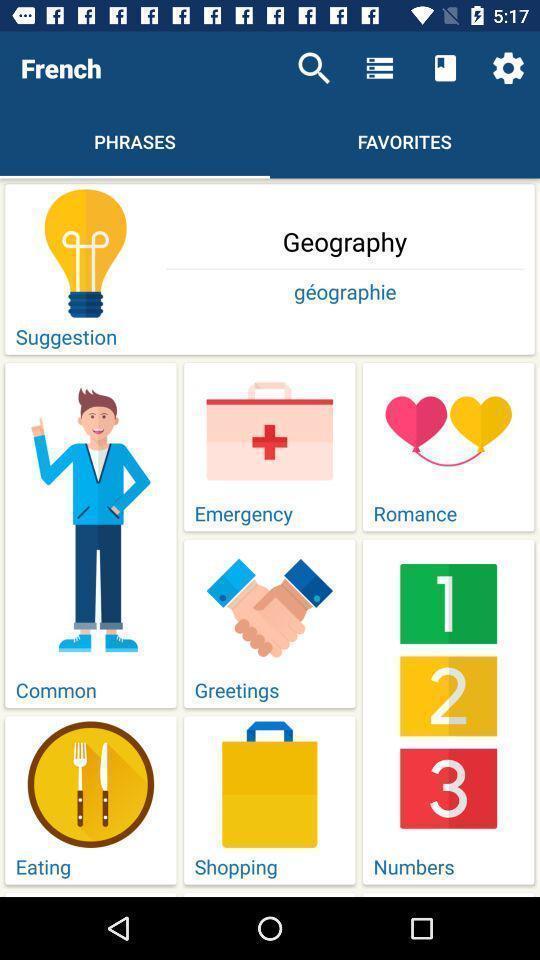What details can you identify in this image? Screen displaying multiple options in a language learning application. 